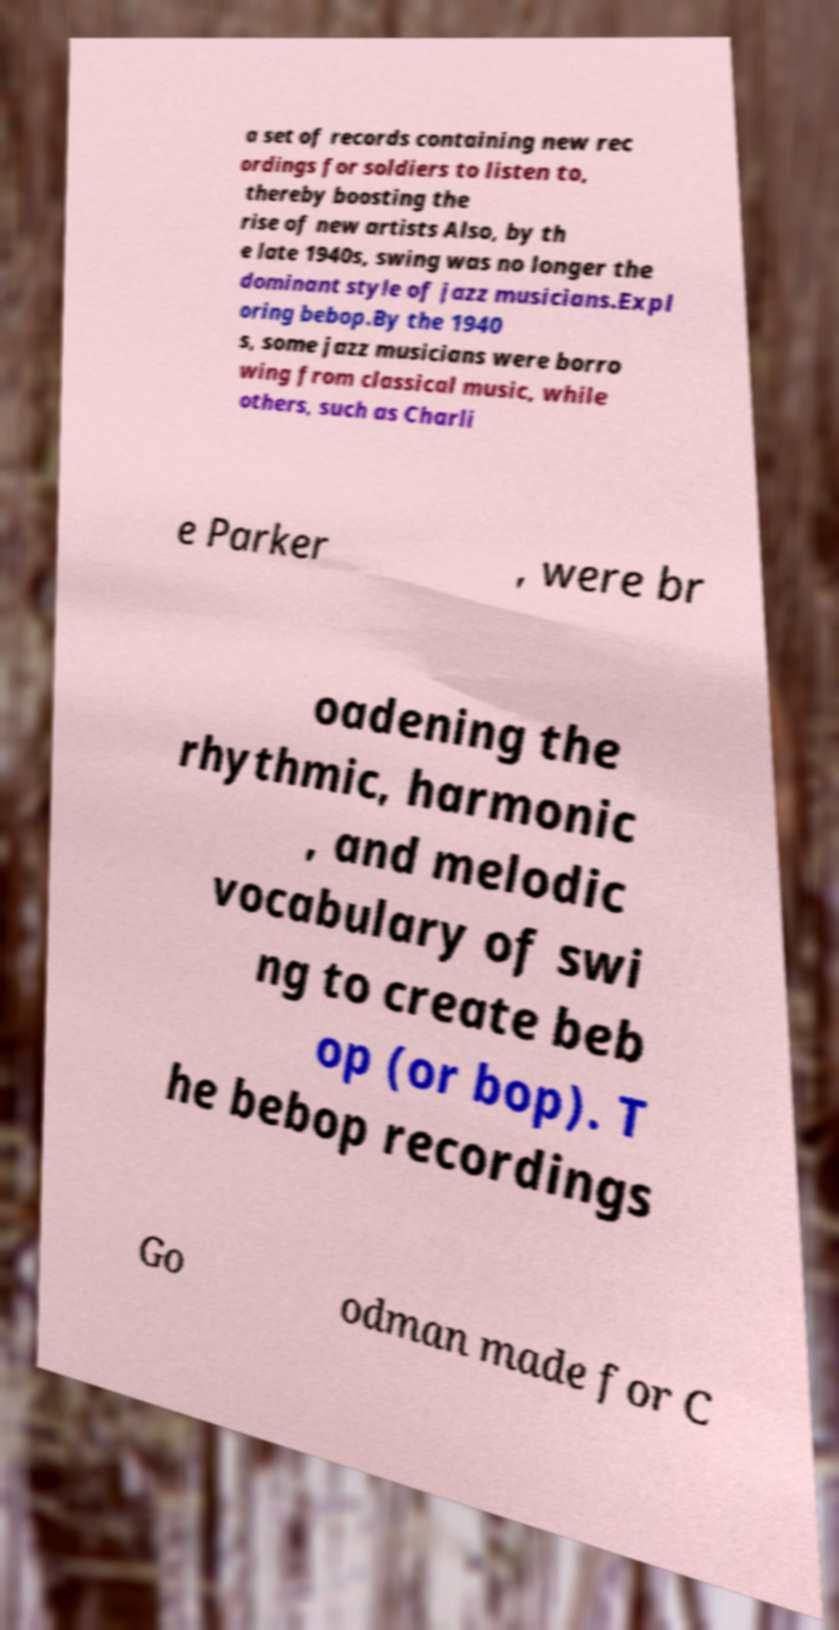Please read and relay the text visible in this image. What does it say? a set of records containing new rec ordings for soldiers to listen to, thereby boosting the rise of new artists Also, by th e late 1940s, swing was no longer the dominant style of jazz musicians.Expl oring bebop.By the 1940 s, some jazz musicians were borro wing from classical music, while others, such as Charli e Parker , were br oadening the rhythmic, harmonic , and melodic vocabulary of swi ng to create beb op (or bop). T he bebop recordings Go odman made for C 